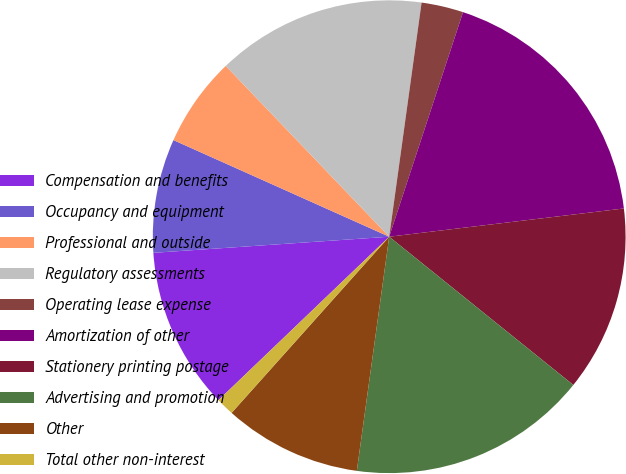Convert chart to OTSL. <chart><loc_0><loc_0><loc_500><loc_500><pie_chart><fcel>Compensation and benefits<fcel>Occupancy and equipment<fcel>Professional and outside<fcel>Regulatory assessments<fcel>Operating lease expense<fcel>Amortization of other<fcel>Stationery printing postage<fcel>Advertising and promotion<fcel>Other<fcel>Total other non-interest<nl><fcel>11.07%<fcel>7.79%<fcel>6.15%<fcel>14.34%<fcel>2.87%<fcel>18.04%<fcel>12.7%<fcel>16.4%<fcel>9.43%<fcel>1.23%<nl></chart> 